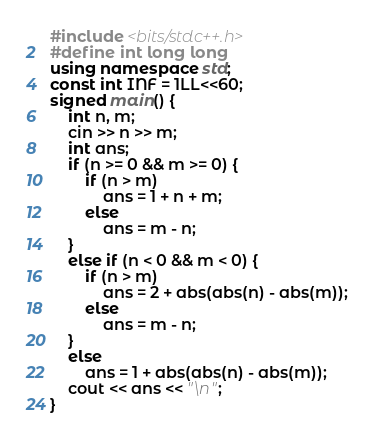Convert code to text. <code><loc_0><loc_0><loc_500><loc_500><_C++_>#include <bits/stdc++.h>
#define int long long
using namespace std;
const int INF = 1LL<<60;
signed main() {
    int n, m;
    cin >> n >> m;
    int ans;
    if (n >= 0 && m >= 0) {
        if (n > m)
            ans = 1 + n + m;
        else
            ans = m - n;
    }
    else if (n < 0 && m < 0) {
        if (n > m)
            ans = 2 + abs(abs(n) - abs(m));
        else
            ans = m - n;
    }
    else
        ans = 1 + abs(abs(n) - abs(m));
    cout << ans << "\n";
}
</code> 